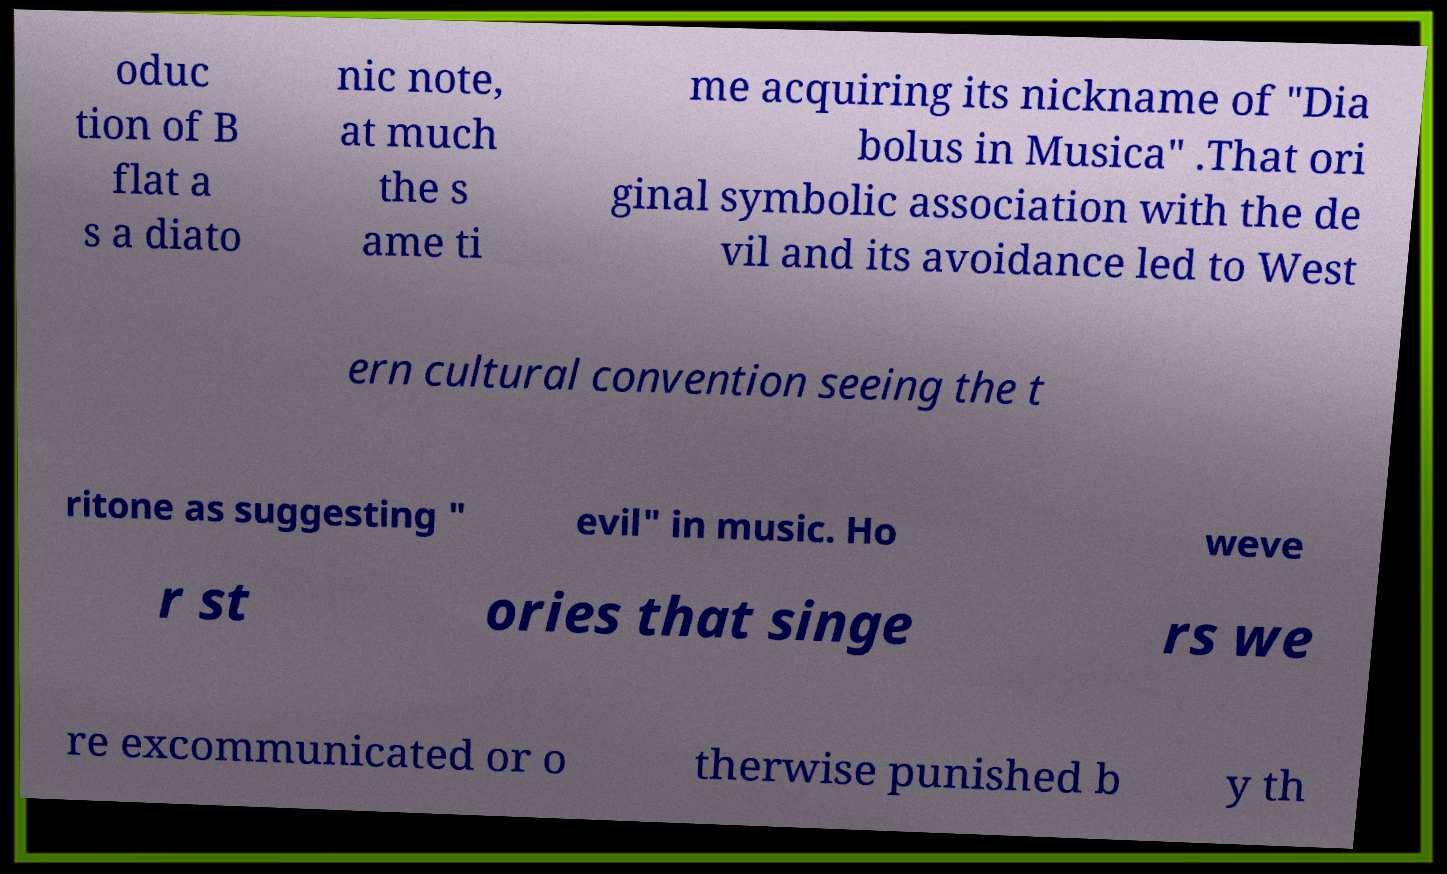Can you accurately transcribe the text from the provided image for me? oduc tion of B flat a s a diato nic note, at much the s ame ti me acquiring its nickname of "Dia bolus in Musica" .That ori ginal symbolic association with the de vil and its avoidance led to West ern cultural convention seeing the t ritone as suggesting " evil" in music. Ho weve r st ories that singe rs we re excommunicated or o therwise punished b y th 